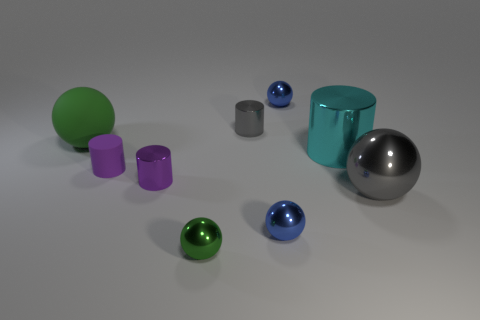Is there another small gray cylinder that has the same material as the small gray cylinder?
Keep it short and to the point. No. What color is the ball to the right of the blue metallic object that is behind the green thing on the left side of the green metal ball?
Provide a succinct answer. Gray. What number of yellow things are shiny spheres or matte spheres?
Offer a very short reply. 0. How many other matte things are the same shape as the big gray object?
Offer a very short reply. 1. There is a purple matte thing that is the same size as the gray metal cylinder; what is its shape?
Provide a short and direct response. Cylinder. Are there any balls in front of the small matte cylinder?
Give a very brief answer. Yes. There is a large thing on the right side of the large cyan cylinder; is there a small gray shiny cylinder right of it?
Your response must be concise. No. Are there fewer blue spheres that are to the right of the large cyan thing than small metal balls that are on the left side of the gray cylinder?
Provide a short and direct response. Yes. Are there any other things that have the same size as the purple shiny cylinder?
Provide a short and direct response. Yes. The cyan shiny object is what shape?
Ensure brevity in your answer.  Cylinder. 